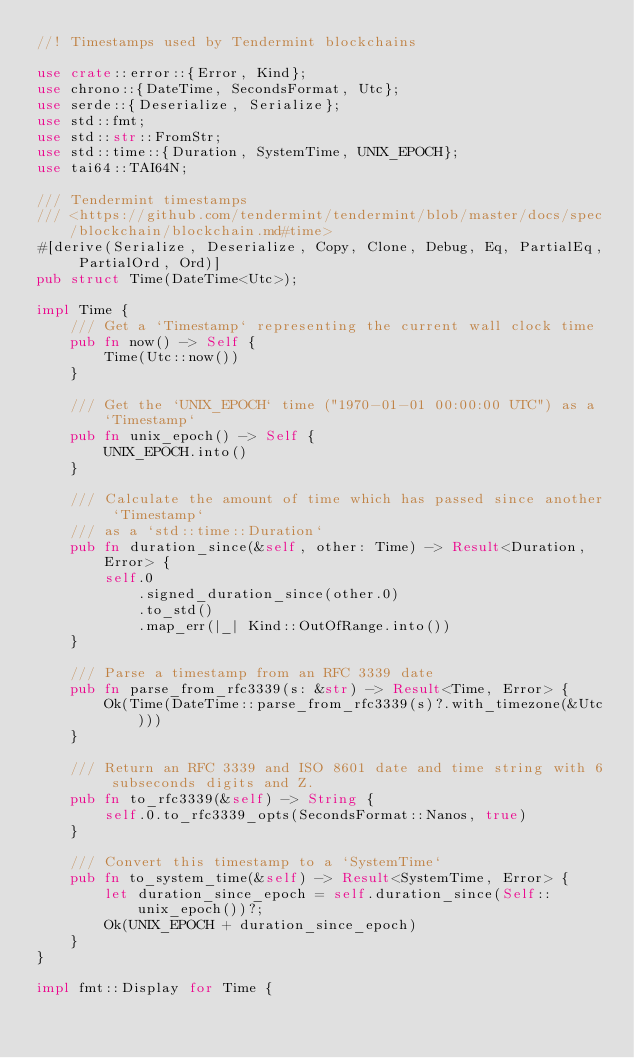Convert code to text. <code><loc_0><loc_0><loc_500><loc_500><_Rust_>//! Timestamps used by Tendermint blockchains

use crate::error::{Error, Kind};
use chrono::{DateTime, SecondsFormat, Utc};
use serde::{Deserialize, Serialize};
use std::fmt;
use std::str::FromStr;
use std::time::{Duration, SystemTime, UNIX_EPOCH};
use tai64::TAI64N;

/// Tendermint timestamps
/// <https://github.com/tendermint/tendermint/blob/master/docs/spec/blockchain/blockchain.md#time>
#[derive(Serialize, Deserialize, Copy, Clone, Debug, Eq, PartialEq, PartialOrd, Ord)]
pub struct Time(DateTime<Utc>);

impl Time {
    /// Get a `Timestamp` representing the current wall clock time
    pub fn now() -> Self {
        Time(Utc::now())
    }

    /// Get the `UNIX_EPOCH` time ("1970-01-01 00:00:00 UTC") as a `Timestamp`
    pub fn unix_epoch() -> Self {
        UNIX_EPOCH.into()
    }

    /// Calculate the amount of time which has passed since another `Timestamp`
    /// as a `std::time::Duration`
    pub fn duration_since(&self, other: Time) -> Result<Duration, Error> {
        self.0
            .signed_duration_since(other.0)
            .to_std()
            .map_err(|_| Kind::OutOfRange.into())
    }

    /// Parse a timestamp from an RFC 3339 date
    pub fn parse_from_rfc3339(s: &str) -> Result<Time, Error> {
        Ok(Time(DateTime::parse_from_rfc3339(s)?.with_timezone(&Utc)))
    }

    /// Return an RFC 3339 and ISO 8601 date and time string with 6 subseconds digits and Z.
    pub fn to_rfc3339(&self) -> String {
        self.0.to_rfc3339_opts(SecondsFormat::Nanos, true)
    }

    /// Convert this timestamp to a `SystemTime`
    pub fn to_system_time(&self) -> Result<SystemTime, Error> {
        let duration_since_epoch = self.duration_since(Self::unix_epoch())?;
        Ok(UNIX_EPOCH + duration_since_epoch)
    }
}

impl fmt::Display for Time {</code> 